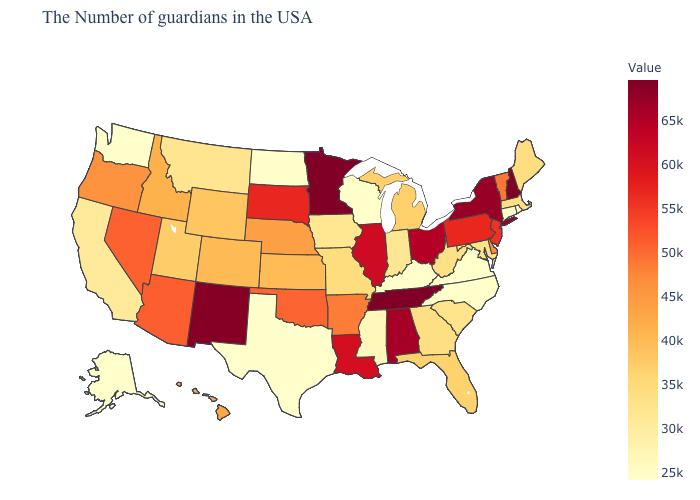Does North Carolina have the lowest value in the USA?
Keep it brief. Yes. Among the states that border Washington , which have the lowest value?
Concise answer only. Idaho. Does California have a lower value than Kansas?
Answer briefly. Yes. Among the states that border Wisconsin , does Iowa have the lowest value?
Be succinct. Yes. Which states have the lowest value in the USA?
Short answer required. Rhode Island, Connecticut, Virginia, North Carolina, Kentucky, Wisconsin, Texas, North Dakota, Washington, Alaska. Does Nevada have a lower value than Alabama?
Write a very short answer. Yes. 